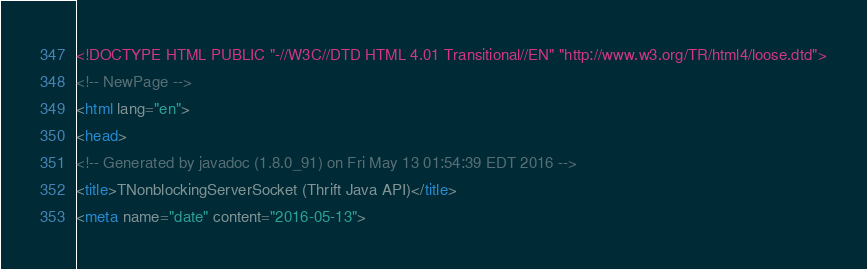<code> <loc_0><loc_0><loc_500><loc_500><_HTML_><!DOCTYPE HTML PUBLIC "-//W3C//DTD HTML 4.01 Transitional//EN" "http://www.w3.org/TR/html4/loose.dtd">
<!-- NewPage -->
<html lang="en">
<head>
<!-- Generated by javadoc (1.8.0_91) on Fri May 13 01:54:39 EDT 2016 -->
<title>TNonblockingServerSocket (Thrift Java API)</title>
<meta name="date" content="2016-05-13"></code> 